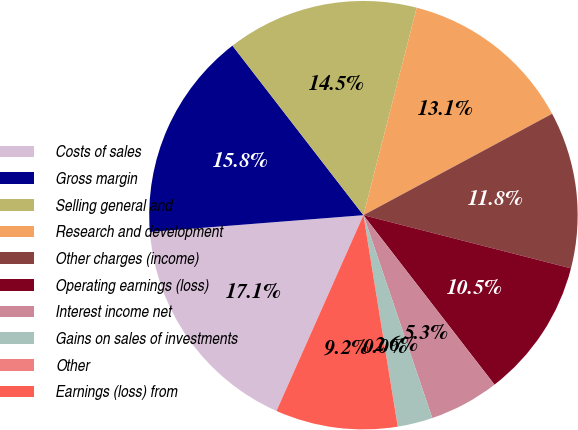<chart> <loc_0><loc_0><loc_500><loc_500><pie_chart><fcel>Costs of sales<fcel>Gross margin<fcel>Selling general and<fcel>Research and development<fcel>Other charges (income)<fcel>Operating earnings (loss)<fcel>Interest income net<fcel>Gains on sales of investments<fcel>Other<fcel>Earnings (loss) from<nl><fcel>17.1%<fcel>15.78%<fcel>14.47%<fcel>13.15%<fcel>11.84%<fcel>10.53%<fcel>5.27%<fcel>2.64%<fcel>0.01%<fcel>9.21%<nl></chart> 